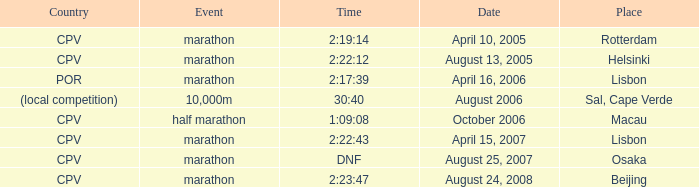What is the event titled country of (area competition)? 10,000m. 